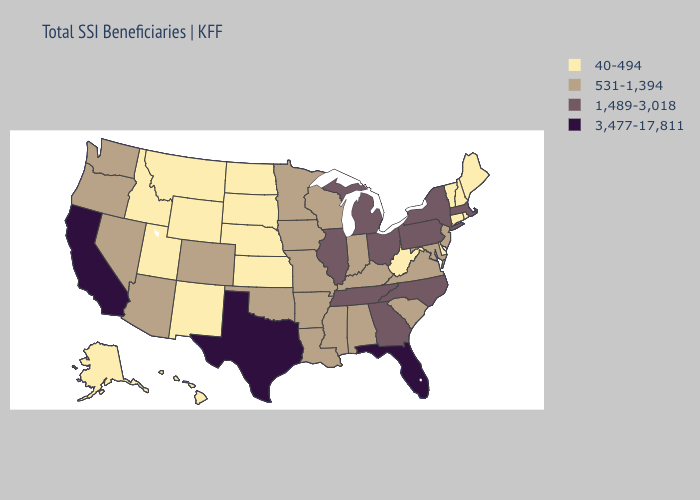Does Wisconsin have a lower value than New York?
Give a very brief answer. Yes. What is the lowest value in the South?
Give a very brief answer. 40-494. Does Hawaii have the lowest value in the USA?
Short answer required. Yes. Is the legend a continuous bar?
Be succinct. No. What is the lowest value in the USA?
Keep it brief. 40-494. What is the value of Indiana?
Keep it brief. 531-1,394. Among the states that border California , which have the lowest value?
Keep it brief. Arizona, Nevada, Oregon. What is the highest value in the West ?
Be succinct. 3,477-17,811. Among the states that border Tennessee , which have the highest value?
Keep it brief. Georgia, North Carolina. What is the lowest value in states that border Arizona?
Short answer required. 40-494. Does Idaho have a lower value than Maine?
Quick response, please. No. What is the value of North Dakota?
Quick response, please. 40-494. What is the lowest value in the West?
Quick response, please. 40-494. Is the legend a continuous bar?
Give a very brief answer. No. Among the states that border Connecticut , which have the highest value?
Write a very short answer. Massachusetts, New York. 